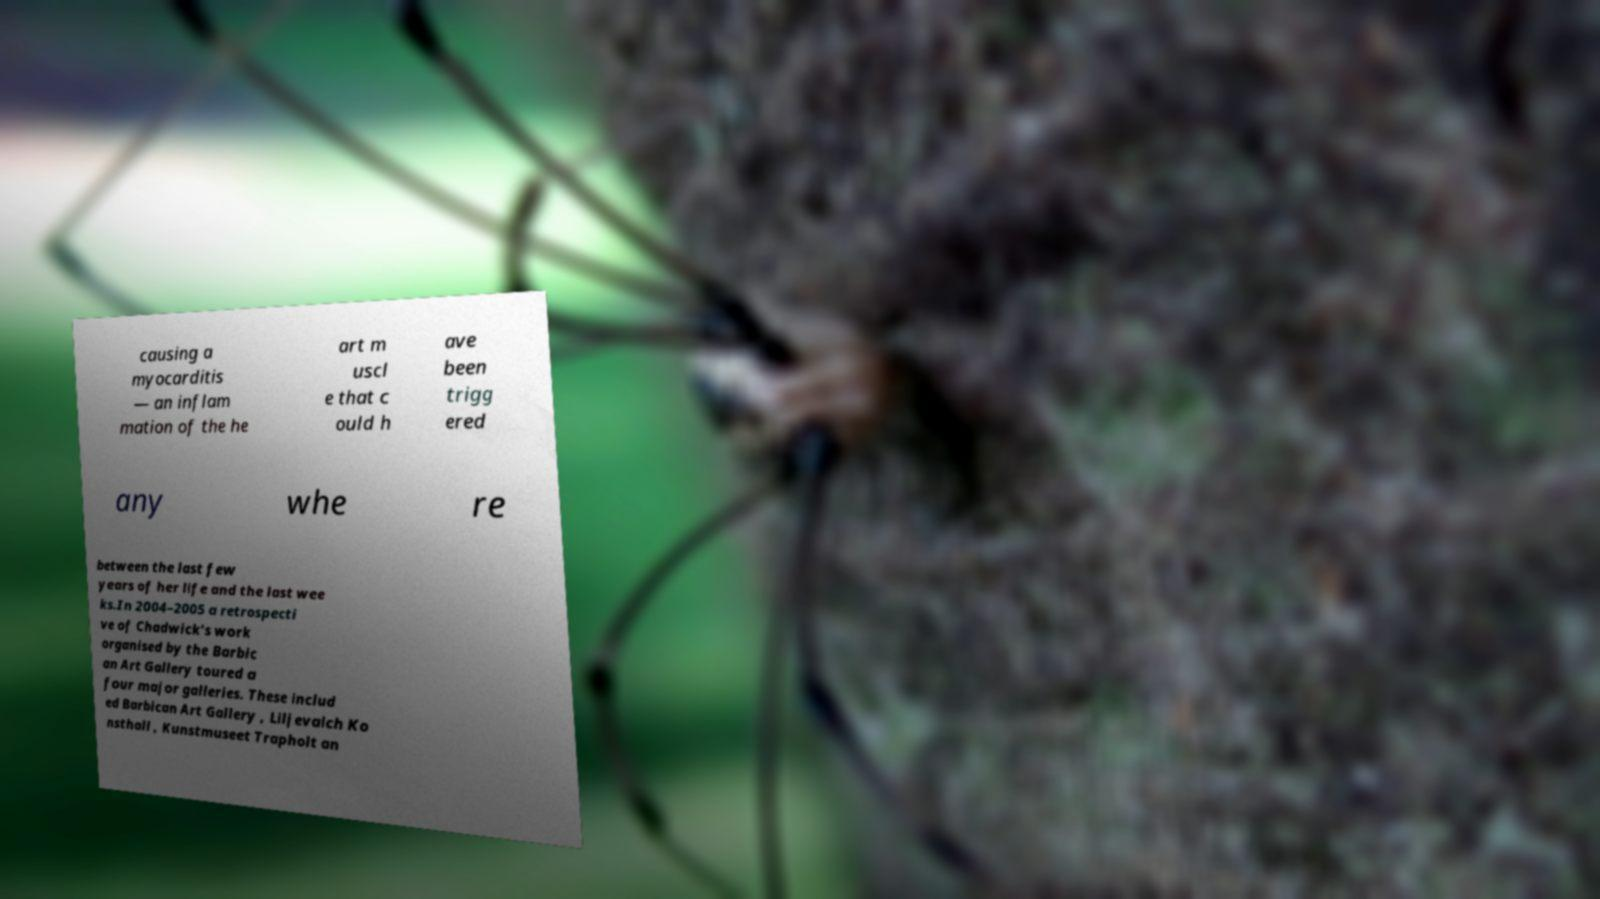Please read and relay the text visible in this image. What does it say? causing a myocarditis — an inflam mation of the he art m uscl e that c ould h ave been trigg ered any whe re between the last few years of her life and the last wee ks.In 2004–2005 a retrospecti ve of Chadwick’s work organised by the Barbic an Art Gallery toured a four major galleries. These includ ed Barbican Art Gallery , Liljevalch Ko nsthall , Kunstmuseet Trapholt an 